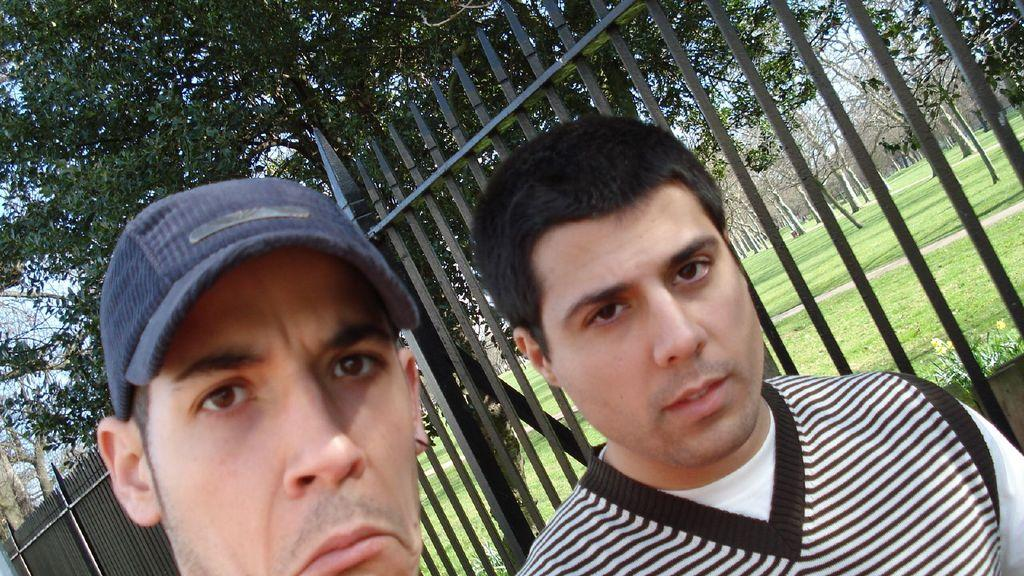Who is present in the image? There are men in the image. What objects can be seen in the image? There are iron grills in the image. What type of vegetation is visible in the image? There are trees in the image. What part of the natural environment is visible in the image? The ground and the sky are visible in the image. What type of cheese is being used to build the iron grills in the image? There is no cheese present in the image, and the iron grills are not being built. 